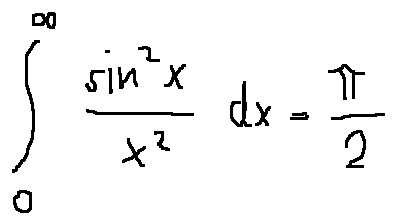Convert formula to latex. <formula><loc_0><loc_0><loc_500><loc_500>\int \lim i t s _ { 0 } ^ { \infty } \frac { \sin ^ { 2 } x } { x ^ { 2 } } d x = \frac { \pi } { 2 }</formula> 